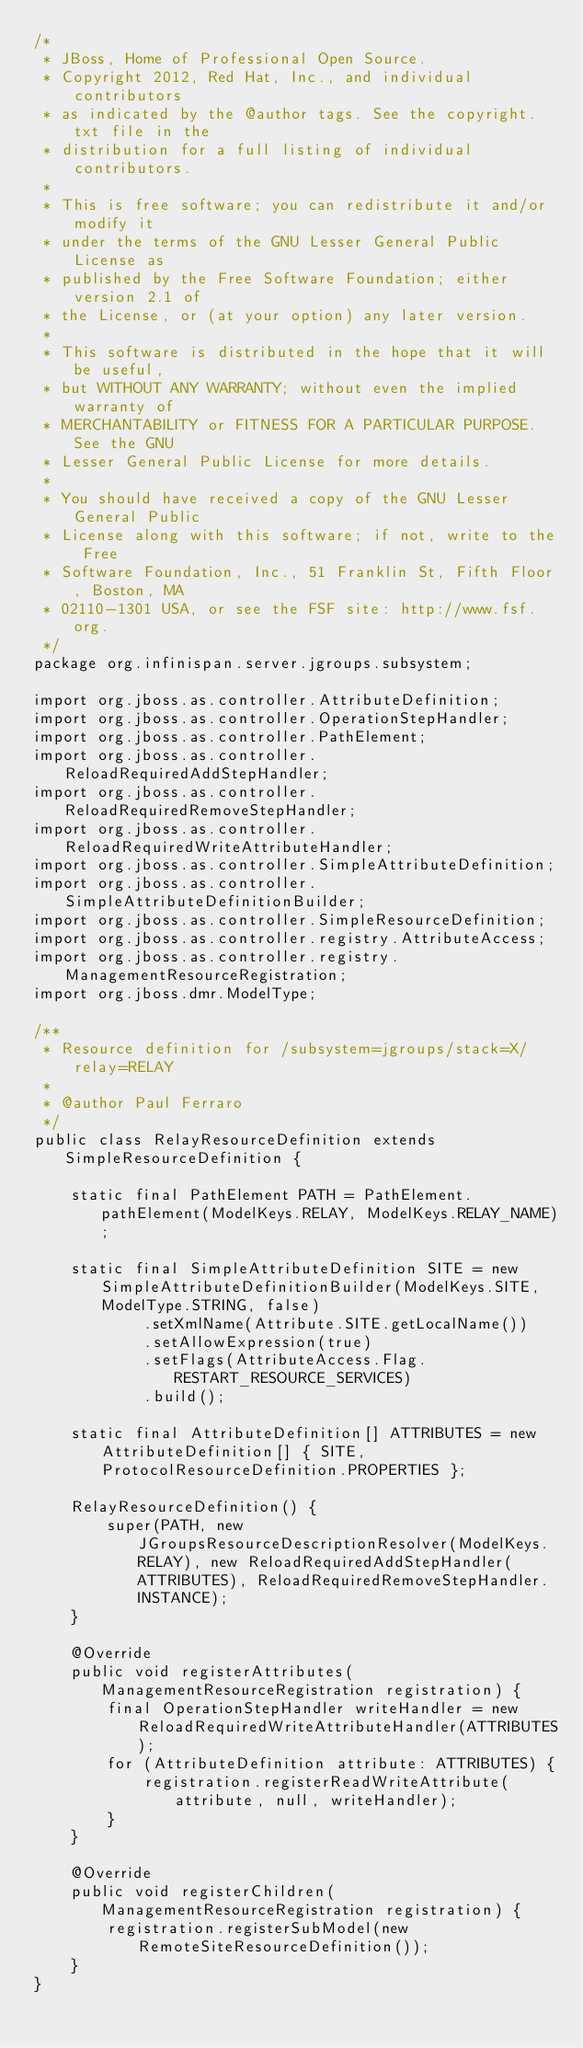<code> <loc_0><loc_0><loc_500><loc_500><_Java_>/*
 * JBoss, Home of Professional Open Source.
 * Copyright 2012, Red Hat, Inc., and individual contributors
 * as indicated by the @author tags. See the copyright.txt file in the
 * distribution for a full listing of individual contributors.
 *
 * This is free software; you can redistribute it and/or modify it
 * under the terms of the GNU Lesser General Public License as
 * published by the Free Software Foundation; either version 2.1 of
 * the License, or (at your option) any later version.
 *
 * This software is distributed in the hope that it will be useful,
 * but WITHOUT ANY WARRANTY; without even the implied warranty of
 * MERCHANTABILITY or FITNESS FOR A PARTICULAR PURPOSE. See the GNU
 * Lesser General Public License for more details.
 *
 * You should have received a copy of the GNU Lesser General Public
 * License along with this software; if not, write to the Free
 * Software Foundation, Inc., 51 Franklin St, Fifth Floor, Boston, MA
 * 02110-1301 USA, or see the FSF site: http://www.fsf.org.
 */
package org.infinispan.server.jgroups.subsystem;

import org.jboss.as.controller.AttributeDefinition;
import org.jboss.as.controller.OperationStepHandler;
import org.jboss.as.controller.PathElement;
import org.jboss.as.controller.ReloadRequiredAddStepHandler;
import org.jboss.as.controller.ReloadRequiredRemoveStepHandler;
import org.jboss.as.controller.ReloadRequiredWriteAttributeHandler;
import org.jboss.as.controller.SimpleAttributeDefinition;
import org.jboss.as.controller.SimpleAttributeDefinitionBuilder;
import org.jboss.as.controller.SimpleResourceDefinition;
import org.jboss.as.controller.registry.AttributeAccess;
import org.jboss.as.controller.registry.ManagementResourceRegistration;
import org.jboss.dmr.ModelType;

/**
 * Resource definition for /subsystem=jgroups/stack=X/relay=RELAY
 *
 * @author Paul Ferraro
 */
public class RelayResourceDefinition extends SimpleResourceDefinition {

    static final PathElement PATH = PathElement.pathElement(ModelKeys.RELAY, ModelKeys.RELAY_NAME);

    static final SimpleAttributeDefinition SITE = new SimpleAttributeDefinitionBuilder(ModelKeys.SITE, ModelType.STRING, false)
            .setXmlName(Attribute.SITE.getLocalName())
            .setAllowExpression(true)
            .setFlags(AttributeAccess.Flag.RESTART_RESOURCE_SERVICES)
            .build();

    static final AttributeDefinition[] ATTRIBUTES = new AttributeDefinition[] { SITE, ProtocolResourceDefinition.PROPERTIES };

    RelayResourceDefinition() {
        super(PATH, new JGroupsResourceDescriptionResolver(ModelKeys.RELAY), new ReloadRequiredAddStepHandler(ATTRIBUTES), ReloadRequiredRemoveStepHandler.INSTANCE);
    }

    @Override
    public void registerAttributes(ManagementResourceRegistration registration) {
        final OperationStepHandler writeHandler = new ReloadRequiredWriteAttributeHandler(ATTRIBUTES);
        for (AttributeDefinition attribute: ATTRIBUTES) {
            registration.registerReadWriteAttribute(attribute, null, writeHandler);
        }
    }

    @Override
    public void registerChildren(ManagementResourceRegistration registration) {
        registration.registerSubModel(new RemoteSiteResourceDefinition());
    }
}
</code> 